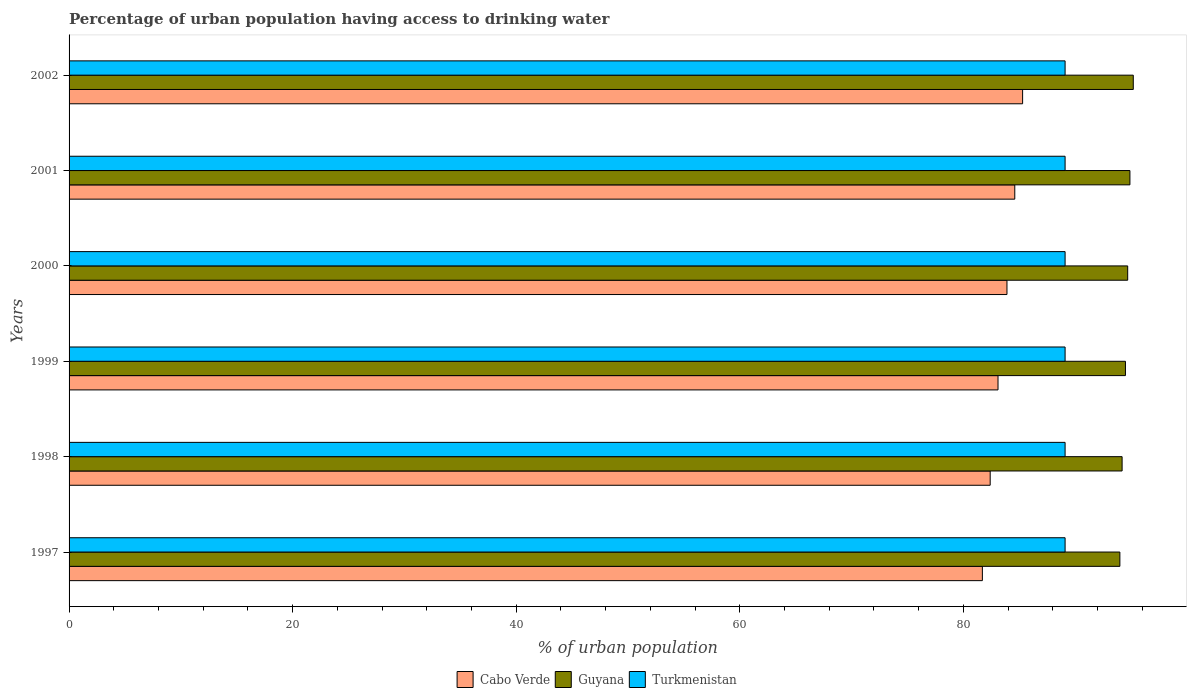Are the number of bars per tick equal to the number of legend labels?
Provide a short and direct response. Yes. Are the number of bars on each tick of the Y-axis equal?
Make the answer very short. Yes. How many bars are there on the 6th tick from the bottom?
Provide a short and direct response. 3. What is the label of the 2nd group of bars from the top?
Your answer should be very brief. 2001. In how many cases, is the number of bars for a given year not equal to the number of legend labels?
Your response must be concise. 0. What is the percentage of urban population having access to drinking water in Cabo Verde in 1999?
Keep it short and to the point. 83.1. Across all years, what is the maximum percentage of urban population having access to drinking water in Turkmenistan?
Offer a very short reply. 89.1. Across all years, what is the minimum percentage of urban population having access to drinking water in Turkmenistan?
Offer a very short reply. 89.1. In which year was the percentage of urban population having access to drinking water in Guyana maximum?
Offer a terse response. 2002. What is the total percentage of urban population having access to drinking water in Cabo Verde in the graph?
Your response must be concise. 501. What is the difference between the percentage of urban population having access to drinking water in Cabo Verde in 1998 and that in 2001?
Keep it short and to the point. -2.2. What is the difference between the percentage of urban population having access to drinking water in Turkmenistan in 1998 and the percentage of urban population having access to drinking water in Guyana in 2001?
Provide a short and direct response. -5.8. What is the average percentage of urban population having access to drinking water in Guyana per year?
Make the answer very short. 94.58. In the year 1997, what is the difference between the percentage of urban population having access to drinking water in Guyana and percentage of urban population having access to drinking water in Cabo Verde?
Provide a succinct answer. 12.3. What is the ratio of the percentage of urban population having access to drinking water in Guyana in 2001 to that in 2002?
Provide a succinct answer. 1. Is the percentage of urban population having access to drinking water in Guyana in 1998 less than that in 2000?
Keep it short and to the point. Yes. Is the difference between the percentage of urban population having access to drinking water in Guyana in 2001 and 2002 greater than the difference between the percentage of urban population having access to drinking water in Cabo Verde in 2001 and 2002?
Your response must be concise. Yes. What is the difference between the highest and the lowest percentage of urban population having access to drinking water in Cabo Verde?
Offer a terse response. 3.6. Is the sum of the percentage of urban population having access to drinking water in Guyana in 1999 and 2002 greater than the maximum percentage of urban population having access to drinking water in Cabo Verde across all years?
Keep it short and to the point. Yes. What does the 3rd bar from the top in 1999 represents?
Keep it short and to the point. Cabo Verde. What does the 2nd bar from the bottom in 1998 represents?
Make the answer very short. Guyana. Are the values on the major ticks of X-axis written in scientific E-notation?
Offer a terse response. No. Does the graph contain grids?
Provide a short and direct response. No. Where does the legend appear in the graph?
Provide a succinct answer. Bottom center. How many legend labels are there?
Ensure brevity in your answer.  3. What is the title of the graph?
Your answer should be very brief. Percentage of urban population having access to drinking water. What is the label or title of the X-axis?
Give a very brief answer. % of urban population. What is the label or title of the Y-axis?
Your response must be concise. Years. What is the % of urban population in Cabo Verde in 1997?
Your answer should be compact. 81.7. What is the % of urban population of Guyana in 1997?
Provide a short and direct response. 94. What is the % of urban population in Turkmenistan in 1997?
Provide a short and direct response. 89.1. What is the % of urban population of Cabo Verde in 1998?
Ensure brevity in your answer.  82.4. What is the % of urban population of Guyana in 1998?
Ensure brevity in your answer.  94.2. What is the % of urban population of Turkmenistan in 1998?
Your answer should be very brief. 89.1. What is the % of urban population in Cabo Verde in 1999?
Your response must be concise. 83.1. What is the % of urban population in Guyana in 1999?
Keep it short and to the point. 94.5. What is the % of urban population in Turkmenistan in 1999?
Ensure brevity in your answer.  89.1. What is the % of urban population of Cabo Verde in 2000?
Keep it short and to the point. 83.9. What is the % of urban population in Guyana in 2000?
Provide a short and direct response. 94.7. What is the % of urban population in Turkmenistan in 2000?
Your response must be concise. 89.1. What is the % of urban population in Cabo Verde in 2001?
Give a very brief answer. 84.6. What is the % of urban population in Guyana in 2001?
Offer a terse response. 94.9. What is the % of urban population in Turkmenistan in 2001?
Ensure brevity in your answer.  89.1. What is the % of urban population in Cabo Verde in 2002?
Give a very brief answer. 85.3. What is the % of urban population in Guyana in 2002?
Your answer should be very brief. 95.2. What is the % of urban population of Turkmenistan in 2002?
Keep it short and to the point. 89.1. Across all years, what is the maximum % of urban population in Cabo Verde?
Make the answer very short. 85.3. Across all years, what is the maximum % of urban population of Guyana?
Offer a terse response. 95.2. Across all years, what is the maximum % of urban population in Turkmenistan?
Your response must be concise. 89.1. Across all years, what is the minimum % of urban population of Cabo Verde?
Give a very brief answer. 81.7. Across all years, what is the minimum % of urban population in Guyana?
Offer a terse response. 94. Across all years, what is the minimum % of urban population in Turkmenistan?
Offer a very short reply. 89.1. What is the total % of urban population of Cabo Verde in the graph?
Your answer should be compact. 501. What is the total % of urban population of Guyana in the graph?
Provide a short and direct response. 567.5. What is the total % of urban population in Turkmenistan in the graph?
Your answer should be very brief. 534.6. What is the difference between the % of urban population of Turkmenistan in 1997 and that in 1998?
Keep it short and to the point. 0. What is the difference between the % of urban population of Guyana in 1997 and that in 1999?
Your answer should be very brief. -0.5. What is the difference between the % of urban population in Cabo Verde in 1997 and that in 2000?
Offer a very short reply. -2.2. What is the difference between the % of urban population of Guyana in 1997 and that in 2000?
Make the answer very short. -0.7. What is the difference between the % of urban population of Cabo Verde in 1997 and that in 2002?
Make the answer very short. -3.6. What is the difference between the % of urban population in Turkmenistan in 1997 and that in 2002?
Keep it short and to the point. 0. What is the difference between the % of urban population of Cabo Verde in 1998 and that in 1999?
Make the answer very short. -0.7. What is the difference between the % of urban population of Guyana in 1998 and that in 1999?
Ensure brevity in your answer.  -0.3. What is the difference between the % of urban population of Turkmenistan in 1998 and that in 2000?
Keep it short and to the point. 0. What is the difference between the % of urban population in Cabo Verde in 1998 and that in 2001?
Offer a very short reply. -2.2. What is the difference between the % of urban population of Guyana in 1998 and that in 2001?
Make the answer very short. -0.7. What is the difference between the % of urban population in Turkmenistan in 1998 and that in 2001?
Your response must be concise. 0. What is the difference between the % of urban population of Cabo Verde in 1998 and that in 2002?
Your response must be concise. -2.9. What is the difference between the % of urban population of Guyana in 1998 and that in 2002?
Give a very brief answer. -1. What is the difference between the % of urban population in Guyana in 1999 and that in 2000?
Ensure brevity in your answer.  -0.2. What is the difference between the % of urban population in Cabo Verde in 1999 and that in 2001?
Provide a short and direct response. -1.5. What is the difference between the % of urban population of Guyana in 1999 and that in 2001?
Ensure brevity in your answer.  -0.4. What is the difference between the % of urban population in Turkmenistan in 1999 and that in 2001?
Your answer should be very brief. 0. What is the difference between the % of urban population of Turkmenistan in 1999 and that in 2002?
Offer a terse response. 0. What is the difference between the % of urban population in Guyana in 2000 and that in 2001?
Provide a short and direct response. -0.2. What is the difference between the % of urban population of Cabo Verde in 2000 and that in 2002?
Offer a terse response. -1.4. What is the difference between the % of urban population in Guyana in 2000 and that in 2002?
Keep it short and to the point. -0.5. What is the difference between the % of urban population of Turkmenistan in 2000 and that in 2002?
Keep it short and to the point. 0. What is the difference between the % of urban population of Cabo Verde in 1997 and the % of urban population of Guyana in 1998?
Offer a very short reply. -12.5. What is the difference between the % of urban population in Guyana in 1997 and the % of urban population in Turkmenistan in 1999?
Provide a succinct answer. 4.9. What is the difference between the % of urban population of Cabo Verde in 1997 and the % of urban population of Guyana in 2000?
Offer a very short reply. -13. What is the difference between the % of urban population of Cabo Verde in 1997 and the % of urban population of Turkmenistan in 2000?
Offer a very short reply. -7.4. What is the difference between the % of urban population of Guyana in 1997 and the % of urban population of Turkmenistan in 2000?
Offer a terse response. 4.9. What is the difference between the % of urban population of Cabo Verde in 1997 and the % of urban population of Turkmenistan in 2001?
Offer a very short reply. -7.4. What is the difference between the % of urban population in Guyana in 1997 and the % of urban population in Turkmenistan in 2001?
Your answer should be very brief. 4.9. What is the difference between the % of urban population of Cabo Verde in 1997 and the % of urban population of Guyana in 2002?
Ensure brevity in your answer.  -13.5. What is the difference between the % of urban population of Guyana in 1997 and the % of urban population of Turkmenistan in 2002?
Your answer should be compact. 4.9. What is the difference between the % of urban population of Cabo Verde in 1998 and the % of urban population of Guyana in 1999?
Provide a succinct answer. -12.1. What is the difference between the % of urban population of Guyana in 1998 and the % of urban population of Turkmenistan in 1999?
Your answer should be compact. 5.1. What is the difference between the % of urban population in Cabo Verde in 1998 and the % of urban population in Turkmenistan in 2000?
Give a very brief answer. -6.7. What is the difference between the % of urban population in Cabo Verde in 1998 and the % of urban population in Guyana in 2001?
Ensure brevity in your answer.  -12.5. What is the difference between the % of urban population in Cabo Verde in 1998 and the % of urban population in Guyana in 2002?
Your answer should be very brief. -12.8. What is the difference between the % of urban population of Cabo Verde in 1998 and the % of urban population of Turkmenistan in 2002?
Your response must be concise. -6.7. What is the difference between the % of urban population of Guyana in 1998 and the % of urban population of Turkmenistan in 2002?
Make the answer very short. 5.1. What is the difference between the % of urban population in Cabo Verde in 1999 and the % of urban population in Guyana in 2000?
Offer a terse response. -11.6. What is the difference between the % of urban population in Cabo Verde in 1999 and the % of urban population in Guyana in 2001?
Your answer should be very brief. -11.8. What is the difference between the % of urban population in Guyana in 1999 and the % of urban population in Turkmenistan in 2001?
Make the answer very short. 5.4. What is the difference between the % of urban population of Cabo Verde in 1999 and the % of urban population of Guyana in 2002?
Make the answer very short. -12.1. What is the difference between the % of urban population in Cabo Verde in 2000 and the % of urban population in Turkmenistan in 2001?
Your response must be concise. -5.2. What is the difference between the % of urban population in Guyana in 2000 and the % of urban population in Turkmenistan in 2001?
Ensure brevity in your answer.  5.6. What is the difference between the % of urban population of Cabo Verde in 2000 and the % of urban population of Turkmenistan in 2002?
Offer a terse response. -5.2. What is the difference between the % of urban population in Guyana in 2000 and the % of urban population in Turkmenistan in 2002?
Give a very brief answer. 5.6. What is the difference between the % of urban population in Cabo Verde in 2001 and the % of urban population in Turkmenistan in 2002?
Your response must be concise. -4.5. What is the average % of urban population of Cabo Verde per year?
Offer a terse response. 83.5. What is the average % of urban population in Guyana per year?
Provide a succinct answer. 94.58. What is the average % of urban population of Turkmenistan per year?
Offer a very short reply. 89.1. In the year 1997, what is the difference between the % of urban population in Cabo Verde and % of urban population in Guyana?
Give a very brief answer. -12.3. In the year 1997, what is the difference between the % of urban population in Cabo Verde and % of urban population in Turkmenistan?
Provide a short and direct response. -7.4. In the year 1997, what is the difference between the % of urban population of Guyana and % of urban population of Turkmenistan?
Make the answer very short. 4.9. In the year 1998, what is the difference between the % of urban population in Cabo Verde and % of urban population in Guyana?
Offer a terse response. -11.8. In the year 1999, what is the difference between the % of urban population of Cabo Verde and % of urban population of Turkmenistan?
Your answer should be very brief. -6. In the year 1999, what is the difference between the % of urban population of Guyana and % of urban population of Turkmenistan?
Your answer should be very brief. 5.4. In the year 2000, what is the difference between the % of urban population in Cabo Verde and % of urban population in Guyana?
Your answer should be very brief. -10.8. In the year 2000, what is the difference between the % of urban population of Cabo Verde and % of urban population of Turkmenistan?
Make the answer very short. -5.2. In the year 2001, what is the difference between the % of urban population of Cabo Verde and % of urban population of Turkmenistan?
Provide a short and direct response. -4.5. In the year 2001, what is the difference between the % of urban population of Guyana and % of urban population of Turkmenistan?
Ensure brevity in your answer.  5.8. In the year 2002, what is the difference between the % of urban population of Cabo Verde and % of urban population of Guyana?
Your answer should be very brief. -9.9. In the year 2002, what is the difference between the % of urban population in Guyana and % of urban population in Turkmenistan?
Offer a terse response. 6.1. What is the ratio of the % of urban population of Guyana in 1997 to that in 1998?
Ensure brevity in your answer.  1. What is the ratio of the % of urban population in Turkmenistan in 1997 to that in 1998?
Make the answer very short. 1. What is the ratio of the % of urban population of Cabo Verde in 1997 to that in 1999?
Provide a short and direct response. 0.98. What is the ratio of the % of urban population of Guyana in 1997 to that in 1999?
Provide a short and direct response. 0.99. What is the ratio of the % of urban population in Turkmenistan in 1997 to that in 1999?
Offer a terse response. 1. What is the ratio of the % of urban population in Cabo Verde in 1997 to that in 2000?
Your response must be concise. 0.97. What is the ratio of the % of urban population of Guyana in 1997 to that in 2000?
Provide a short and direct response. 0.99. What is the ratio of the % of urban population of Cabo Verde in 1997 to that in 2001?
Provide a short and direct response. 0.97. What is the ratio of the % of urban population in Cabo Verde in 1997 to that in 2002?
Your answer should be compact. 0.96. What is the ratio of the % of urban population of Guyana in 1997 to that in 2002?
Ensure brevity in your answer.  0.99. What is the ratio of the % of urban population in Turkmenistan in 1997 to that in 2002?
Keep it short and to the point. 1. What is the ratio of the % of urban population of Cabo Verde in 1998 to that in 1999?
Your answer should be very brief. 0.99. What is the ratio of the % of urban population of Turkmenistan in 1998 to that in 1999?
Keep it short and to the point. 1. What is the ratio of the % of urban population in Cabo Verde in 1998 to that in 2000?
Offer a very short reply. 0.98. What is the ratio of the % of urban population in Turkmenistan in 1998 to that in 2000?
Your response must be concise. 1. What is the ratio of the % of urban population of Cabo Verde in 1998 to that in 2001?
Give a very brief answer. 0.97. What is the ratio of the % of urban population of Guyana in 1998 to that in 2001?
Make the answer very short. 0.99. What is the ratio of the % of urban population in Cabo Verde in 1998 to that in 2002?
Give a very brief answer. 0.97. What is the ratio of the % of urban population of Turkmenistan in 1998 to that in 2002?
Your answer should be compact. 1. What is the ratio of the % of urban population in Turkmenistan in 1999 to that in 2000?
Make the answer very short. 1. What is the ratio of the % of urban population of Cabo Verde in 1999 to that in 2001?
Provide a succinct answer. 0.98. What is the ratio of the % of urban population of Cabo Verde in 1999 to that in 2002?
Your response must be concise. 0.97. What is the ratio of the % of urban population in Turkmenistan in 1999 to that in 2002?
Your answer should be very brief. 1. What is the ratio of the % of urban population in Cabo Verde in 2000 to that in 2001?
Your answer should be very brief. 0.99. What is the ratio of the % of urban population in Guyana in 2000 to that in 2001?
Ensure brevity in your answer.  1. What is the ratio of the % of urban population in Cabo Verde in 2000 to that in 2002?
Offer a terse response. 0.98. What is the ratio of the % of urban population of Cabo Verde in 2001 to that in 2002?
Ensure brevity in your answer.  0.99. What is the ratio of the % of urban population in Guyana in 2001 to that in 2002?
Provide a short and direct response. 1. What is the ratio of the % of urban population in Turkmenistan in 2001 to that in 2002?
Provide a succinct answer. 1. What is the difference between the highest and the second highest % of urban population of Cabo Verde?
Give a very brief answer. 0.7. What is the difference between the highest and the second highest % of urban population in Turkmenistan?
Give a very brief answer. 0. What is the difference between the highest and the lowest % of urban population in Guyana?
Provide a short and direct response. 1.2. What is the difference between the highest and the lowest % of urban population in Turkmenistan?
Ensure brevity in your answer.  0. 